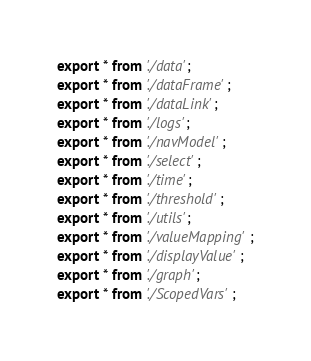<code> <loc_0><loc_0><loc_500><loc_500><_TypeScript_>export * from './data';
export * from './dataFrame';
export * from './dataLink';
export * from './logs';
export * from './navModel';
export * from './select';
export * from './time';
export * from './threshold';
export * from './utils';
export * from './valueMapping';
export * from './displayValue';
export * from './graph';
export * from './ScopedVars';
</code> 